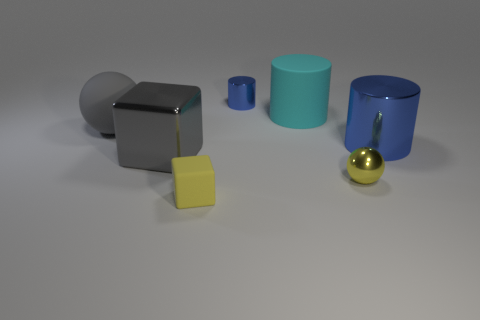Subtract all metallic cylinders. How many cylinders are left? 1 Subtract all brown balls. How many blue cylinders are left? 2 Subtract 1 cylinders. How many cylinders are left? 2 Add 2 purple metallic spheres. How many objects exist? 9 Subtract all cylinders. How many objects are left? 4 Subtract all purple cylinders. Subtract all green spheres. How many cylinders are left? 3 Add 7 tiny shiny spheres. How many tiny shiny spheres are left? 8 Add 5 brown matte cubes. How many brown matte cubes exist? 5 Subtract 0 brown cubes. How many objects are left? 7 Subtract all cyan matte cylinders. Subtract all large green cylinders. How many objects are left? 6 